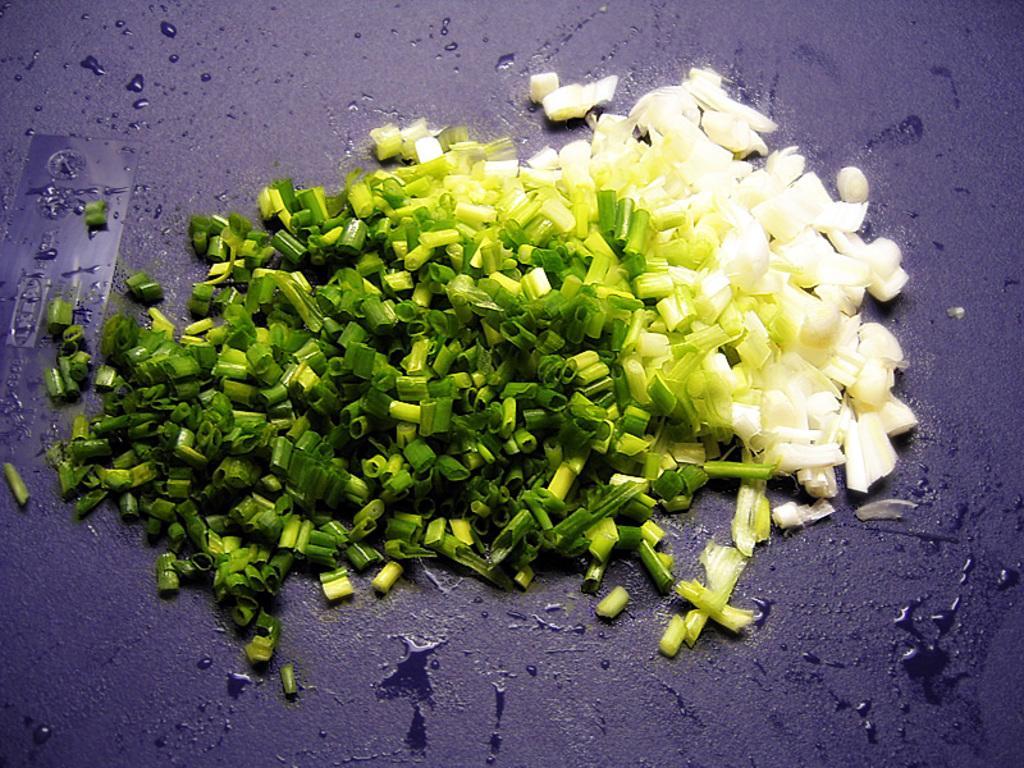Could you give a brief overview of what you see in this image? In this image I can see few vegetables on the gray color surface and the vegetables are in white and green color. 